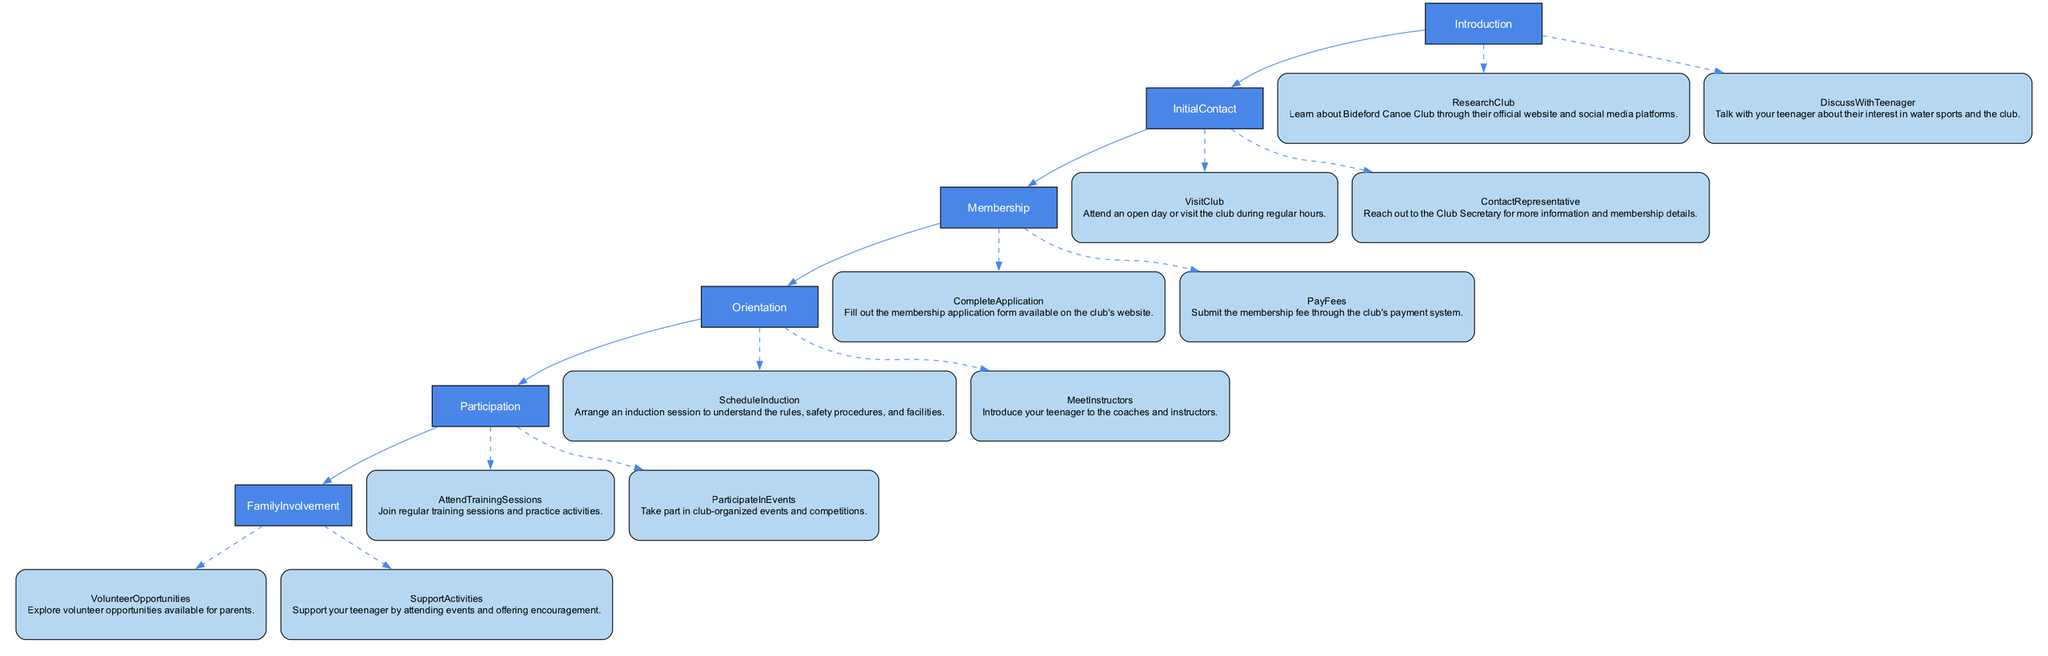What is the first step to join Bideford Canoe Club? The diagram indicates that the first main step is "Introduction," which covers initial actions like researching the club and discussing with your teenager.
Answer: Introduction How many main steps are there in the process? There are six main steps listed in the diagram: Introduction, Initial Contact, Membership, Orientation, Participation, and Family Involvement.
Answer: 6 What should you do after completing the membership application? According to the diagram, after completing the application, you should "Pay Fees," which involves submitting the membership fee.
Answer: Pay Fees Which sub-step involves understanding safety procedures? The sub-step "Schedule Induction" under "Orientation" relates to understanding the rules, safety procedures, and facilities of the club.
Answer: Schedule Induction In what section would you find volunteer opportunities? Volunteer opportunities can be found in the "Family Involvement" section, which encourages parents to explore options for participation.
Answer: Family Involvement What is the relationship between 'Attend Training Sessions' and 'Participate in Events'? Both 'Attend Training Sessions' and 'Participate in Events' are sub-steps under the main step 'Participation,' indicating that they contribute to being actively involved in the club's activities.
Answer: Participation What step requires contacting the Club Secretary for more information? The action of reaching out to the Club Secretary is part of the "Initial Contact" step, which is crucial for gathering details about membership.
Answer: Initial Contact What are the two main actions in the 'Membership' step? The two main actions in the 'Membership' step, as depicted in the diagram, are "Complete Application" and "Pay Fees."
Answer: Complete Application, Pay Fees What is the purpose of the 'Orientation' step? The 'Orientation' step is intended for introducing new members to the club's rules, safety procedures, and instructors, ensuring they feel informed and prepared.
Answer: Introduction to rules and instructors 